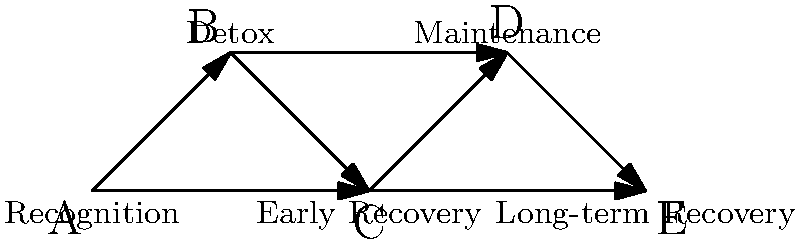In the graph representing stages of addiction recovery, what is the minimum number of stages one must go through to reach long-term recovery (E) from the recognition stage (A), and what does this path represent in terms of recovery? To solve this problem, we need to analyze the graph and find the shortest path from vertex A (Recognition) to vertex E (Long-term Recovery). Let's break it down step-by-step:

1. Identify all possible paths from A to E:
   - A → B → C → D → E
   - A → B → D → E
   - A → C → D → E
   - A → C → E

2. Count the number of edges (transitions between stages) in each path:
   - A → B → C → D → E: 4 edges
   - A → B → D → E: 3 edges
   - A → C → D → E: 3 edges
   - A → C → E: 2 edges

3. The shortest path is A → C → E, which has 2 edges and includes 3 stages (Recognition, Early Recovery, and Long-term Recovery).

4. Interpret this path in terms of recovery:
   This shortest path represents a direct progression from recognition of the addiction problem to early recovery, and then to long-term recovery. It suggests that some individuals may be able to achieve long-term recovery without going through formal detox or a prolonged maintenance phase.

5. However, it's important to note that this "shortest path" may not be typical or recommended for all individuals. Recovery is a personal journey, and many people benefit from the additional support and structure provided by detox and maintenance stages.

The minimum number of stages one must go through is 3 (including the start and end points), representing the path of Recognition → Early Recovery → Long-term Recovery.
Answer: 3 stages; direct path from recognition to long-term recovery via early recovery 